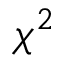Convert formula to latex. <formula><loc_0><loc_0><loc_500><loc_500>\chi ^ { 2 }</formula> 